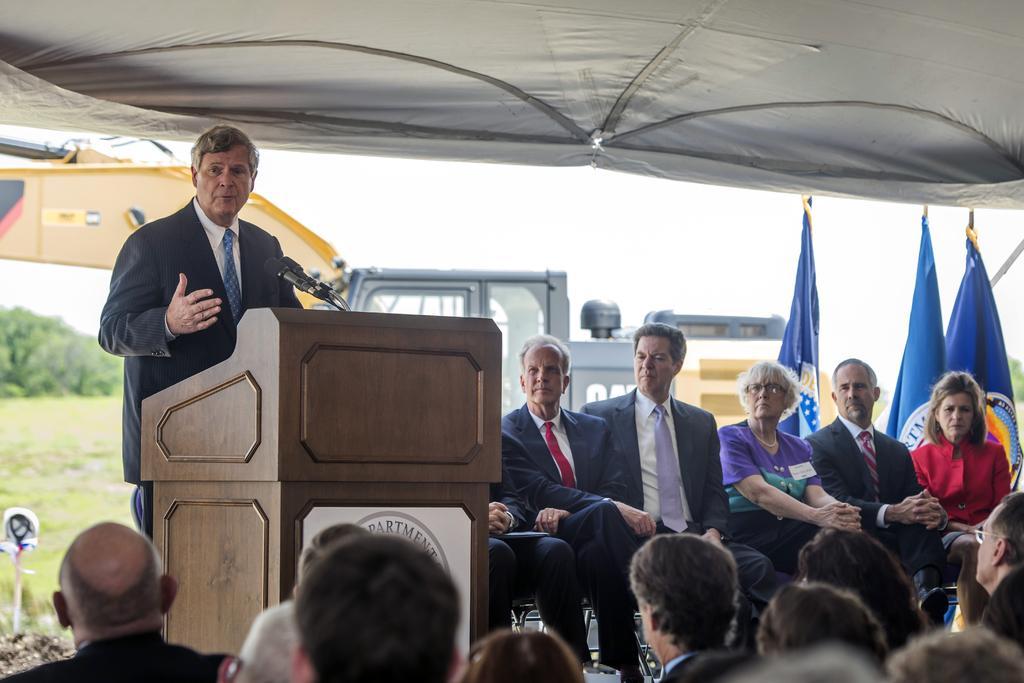Please provide a concise description of this image. There is a man talking on the mike and this is a podium. Here we can see group of people sitting on the chairs. In the background we can see flags, trees, and sky. 